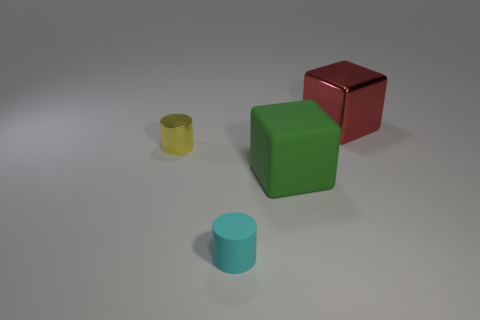Does the big rubber object have the same color as the metal thing on the left side of the big green thing?
Ensure brevity in your answer.  No. What number of other things are there of the same size as the cyan cylinder?
Provide a succinct answer. 1. What number of blocks are either cyan metal objects or small shiny things?
Make the answer very short. 0. There is a tiny thing to the left of the small matte cylinder; is its shape the same as the tiny matte thing?
Provide a succinct answer. Yes. Is the number of objects behind the large rubber cube greater than the number of small cyan blocks?
Your answer should be very brief. Yes. What color is the object that is the same size as the cyan rubber cylinder?
Offer a terse response. Yellow. What number of things are either small cylinders that are behind the big green rubber object or blue objects?
Offer a terse response. 1. There is a cube that is in front of the red shiny block behind the small cyan rubber cylinder; what is it made of?
Your answer should be very brief. Rubber. Is there a big gray cylinder that has the same material as the cyan object?
Offer a terse response. No. There is a big metal cube to the right of the yellow metallic cylinder; are there any metallic cylinders that are left of it?
Keep it short and to the point. Yes. 